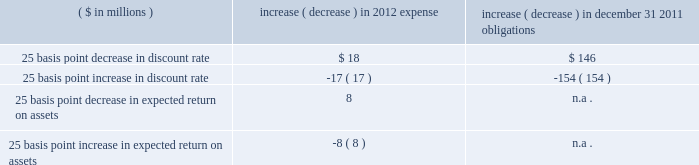Discount rate 2014the assumed discount rate is used to determine the current retirement related benefit plan expense and obligations , and represents the interest rate that is used to determine the present value of future cash flows currently expected to be required to effectively settle a plan 2019s benefit obligations .
The discount rate assumption is determined for each plan by constructing a portfolio of high quality bonds with cash flows that match the estimated outflows for future benefit payments to determine a single equivalent discount rate .
Benefit payments are not only contingent on the terms of a plan , but also on the underlying participant demographics , including current age , and assumed mortality .
We use only bonds that are denominated in u.s .
Dollars , rated aa or better by two of three nationally recognized statistical rating agencies , have a minimum outstanding issue of $ 50 million as of the measurement date , and are not callable , convertible , or index linked .
Since bond yields are generally unavailable beyond 30 years , we assume those rates will remain constant beyond that point .
Taking into consideration the factors noted above , our weighted average discount rate for pensions was 5.23% ( 5.23 % ) and 5.84% ( 5.84 % ) , as of december 31 , 2011 and 2010 , respectively .
Our weighted average discount rate for other postretirement benefits was 4.94% ( 4.94 % ) and 5.58% ( 5.58 % ) as of december 31 , 2011 and 2010 , respectively .
Expected long-term rate of return 2014the expected long-term rate of return on assets is used to calculate net periodic expense , and is based on such factors as historical returns , targeted asset allocations , investment policy , duration , expected future long-term performance of individual asset classes , inflation trends , portfolio volatility , and risk management strategies .
While studies are helpful in understanding current trends and performance , the assumption is based more on longer term and prospective views .
In order to reflect expected lower future market returns , we have reduced the expected long-term rate of return assumption from 8.50% ( 8.50 % ) , used to record 2011 expense , to 8.00% ( 8.00 % ) for 2012 .
The decrease in the expected return on assets assumption is primarily related to lower bond yields and updated return assumptions for equities .
Unless plan assets and benefit obligations are subject to remeasurement during the year , the expected return on pension assets is based on the fair value of plan assets at the beginning of the year .
An increase or decrease of 25 basis points in the discount rate and the expected long-term rate of return assumptions would have had the following approximate impacts on pensions : ( $ in millions ) increase ( decrease ) in 2012 expense increase ( decrease ) in december 31 , 2011 obligations .
Differences arising from actual experience or changes in assumptions might materially affect retirement related benefit plan obligations and the funded status .
Actuarial gains and losses arising from differences from actual experience or changes in assumptions are deferred in accumulated other comprehensive income .
This unrecognized amount is amortized to the extent it exceeds 10% ( 10 % ) of the greater of the plan 2019s benefit obligation or plan assets .
The amortization period for actuarial gains and losses is the estimated average remaining service life of the plan participants , which is approximately 10 years .
Cas expense 2014in addition to providing the methodology for calculating retirement related benefit plan costs , cas also prescribes the method for assigning those costs to specific periods .
While the ultimate liability for such costs under fas and cas is similar , the pattern of cost recognition is different .
The key drivers of cas pension expense include the funded status and the method used to calculate cas reimbursement for each of our plans as well as our expected long-term rate of return on assets assumption .
Unlike fas , cas requires the discount rate to be consistent with the expected long-term rate of return on assets assumption , which changes infrequently given its long-term nature .
As a result , changes in bond or other interest rates generally do not impact cas .
In addition , unlike under fas , we can only allocate pension costs for a plan under cas until such plan is fully funded as determined under erisa requirements .
Other fas and cas considerations 2014we update our estimates of future fas and cas costs at least annually based on factors such as calendar year actual plan asset returns , final census data from the end of the prior year , and other actual and projected experience .
A key driver of the difference between fas and cas expense ( and consequently , the fas/cas adjustment ) is the pattern of earnings and expense recognition for gains and losses that arise when our asset and liability experiences differ from our assumptions under each set of requirements .
Under fas , our net gains and losses exceeding the 10% ( 10 % ) corridor are amortized .
What is the percentage change in the weighted average discount rate for pensions from 2010 to 2011? 
Computations: ((5.23 - 5.84) / 5.84)
Answer: -0.10445. 